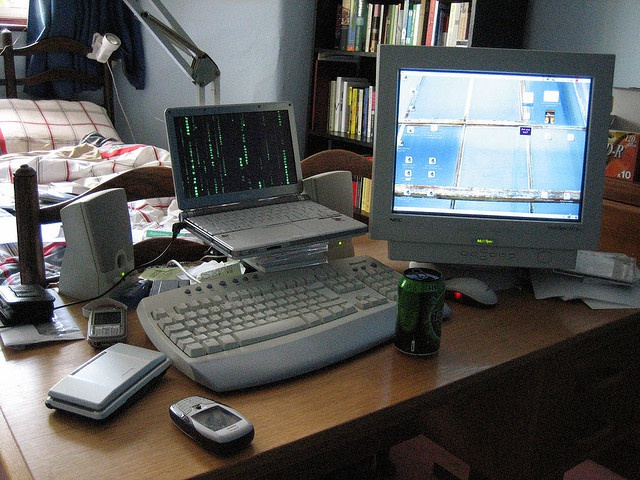Describe the objects in this image and their specific colors. I can see tv in khaki, white, black, lightblue, and purple tones, keyboard in khaki, gray, and black tones, laptop in khaki, black, and gray tones, bed in khaki, white, darkgray, and gray tones, and keyboard in khaki, gray, and black tones in this image. 